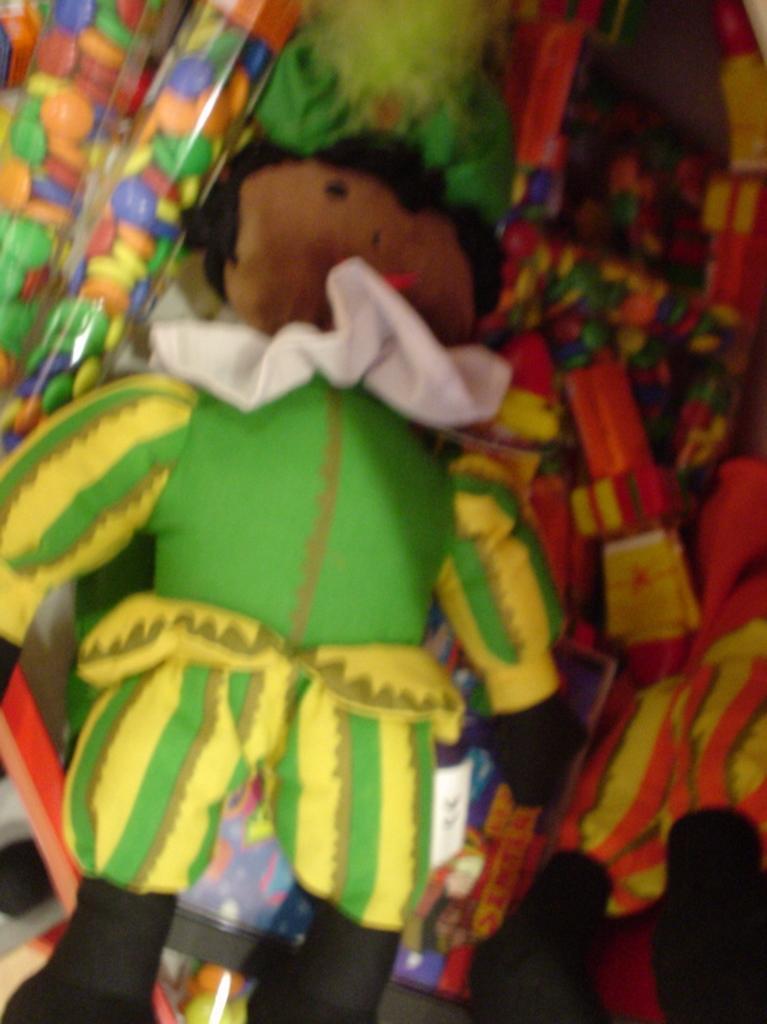Can you describe this image briefly? In this image I can see a doll which is green, yellow, black and brown in color. I can see number of toys around the doll which are colorful. 